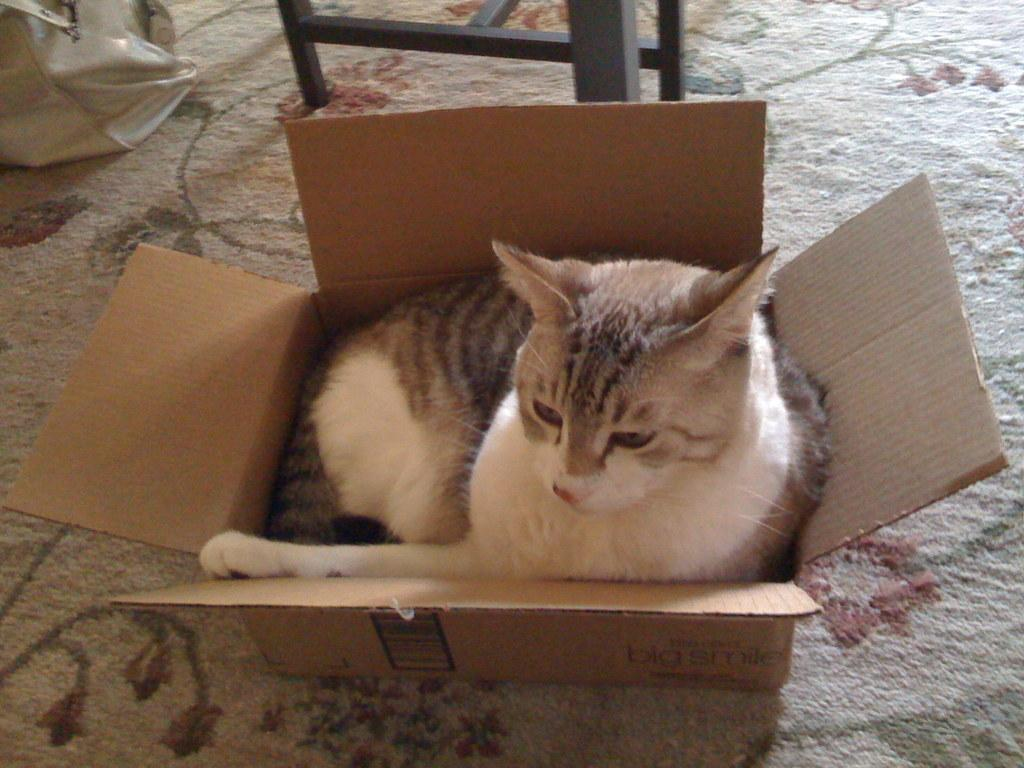What animal is present in the image? There is a cat in the image. Where is the cat sitting? The cat is sitting on a cotton box. What is the cotton box placed on? The cotton box is placed on a carpet. What is in front of the cotton box? There is a wooden structure in front of the cotton box. What is beside the wooden structure? There is a bag beside the wooden structure. What type of mint plant can be seen growing in the field behind the cat? There is no mint plant or field present in the image; it features a cat sitting on a cotton box placed on a carpet. 